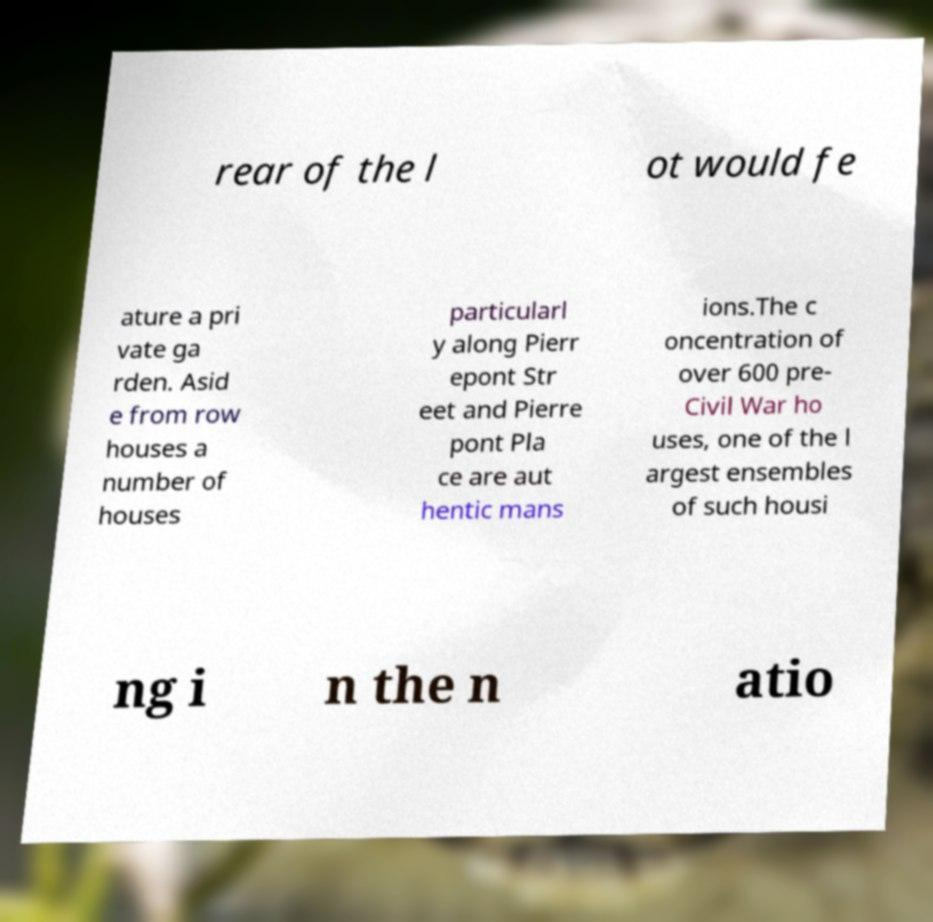Can you accurately transcribe the text from the provided image for me? rear of the l ot would fe ature a pri vate ga rden. Asid e from row houses a number of houses particularl y along Pierr epont Str eet and Pierre pont Pla ce are aut hentic mans ions.The c oncentration of over 600 pre- Civil War ho uses, one of the l argest ensembles of such housi ng i n the n atio 